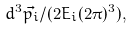<formula> <loc_0><loc_0><loc_500><loc_500>d ^ { 3 } \vec { p _ { i } } / ( 2 E _ { i } ( 2 \pi ) ^ { 3 } ) ,</formula> 